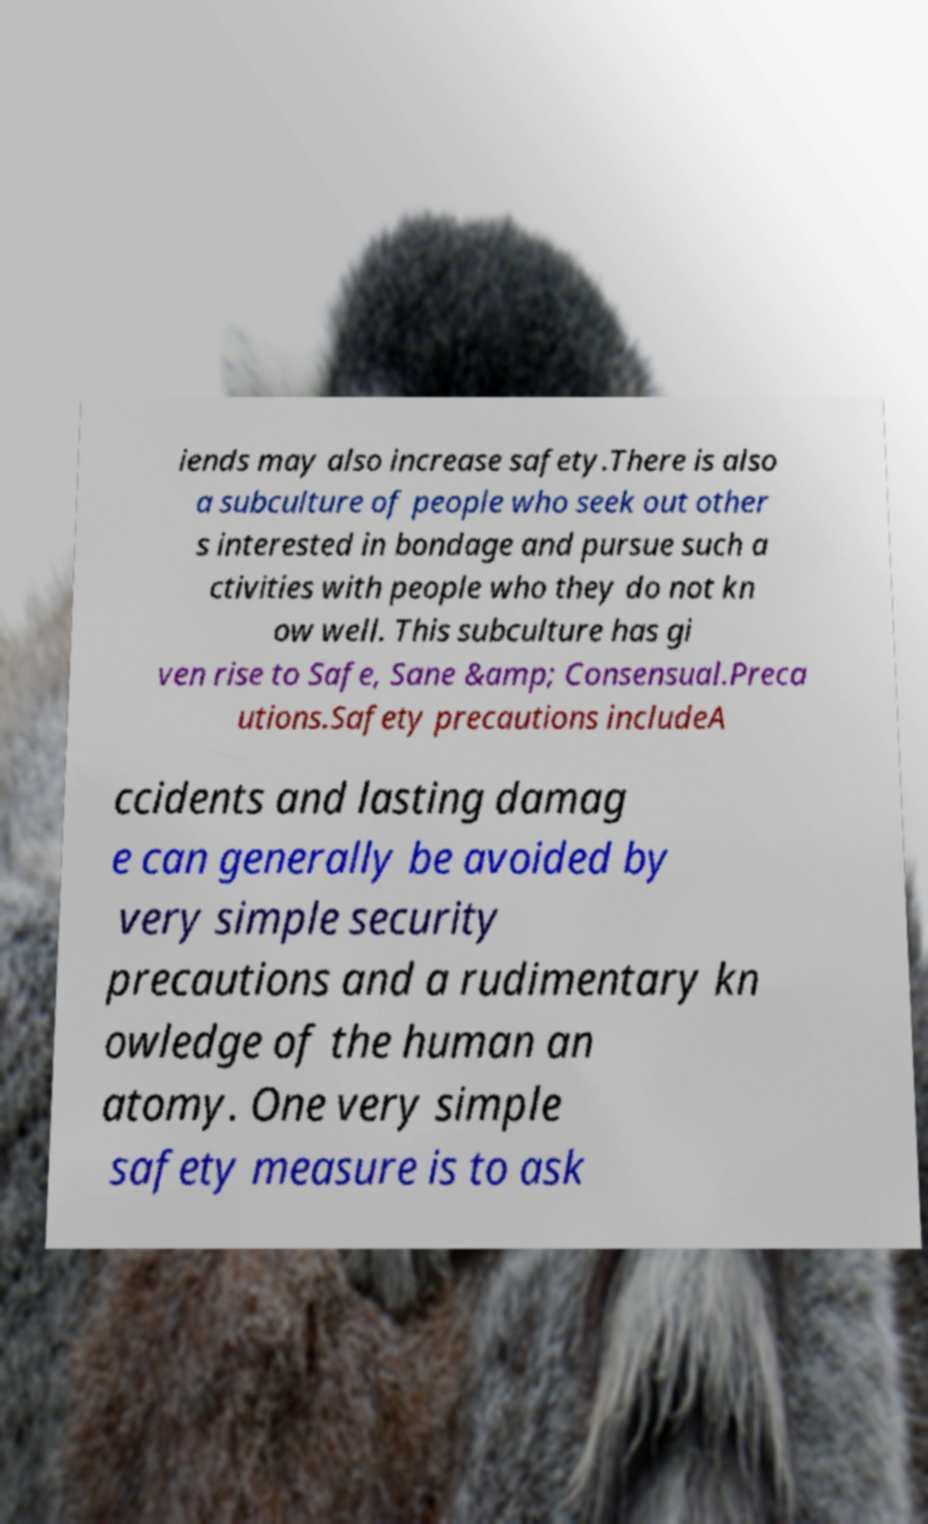There's text embedded in this image that I need extracted. Can you transcribe it verbatim? iends may also increase safety.There is also a subculture of people who seek out other s interested in bondage and pursue such a ctivities with people who they do not kn ow well. This subculture has gi ven rise to Safe, Sane &amp; Consensual.Preca utions.Safety precautions includeA ccidents and lasting damag e can generally be avoided by very simple security precautions and a rudimentary kn owledge of the human an atomy. One very simple safety measure is to ask 